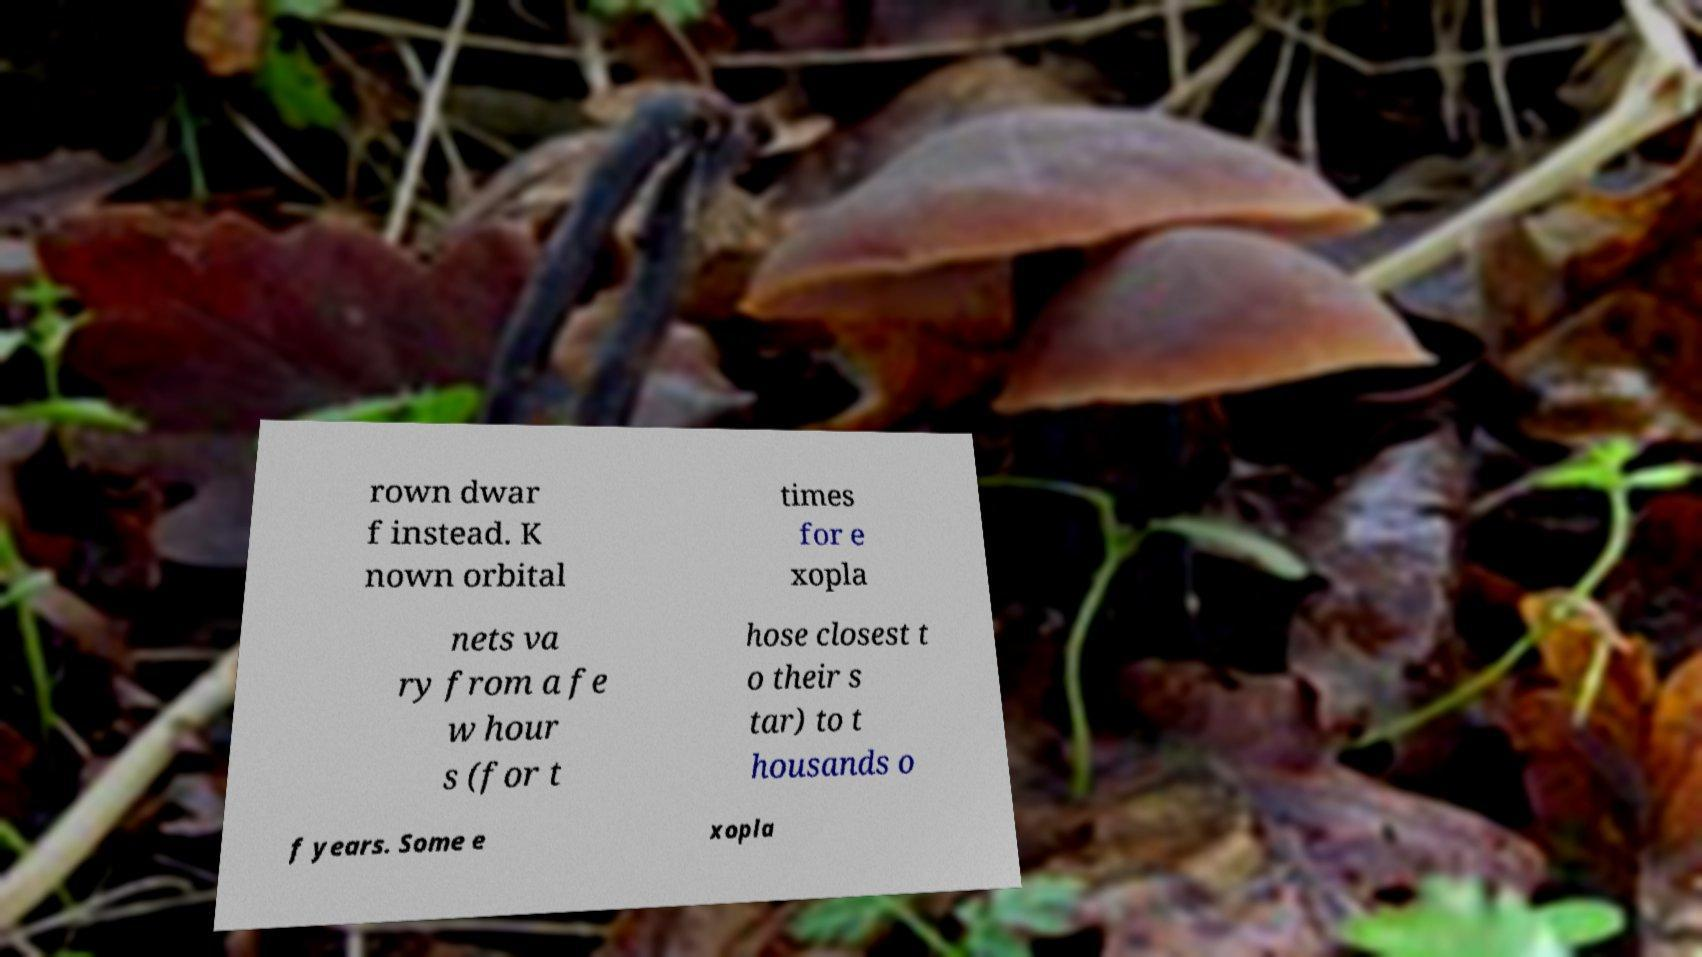Please identify and transcribe the text found in this image. rown dwar f instead. K nown orbital times for e xopla nets va ry from a fe w hour s (for t hose closest t o their s tar) to t housands o f years. Some e xopla 